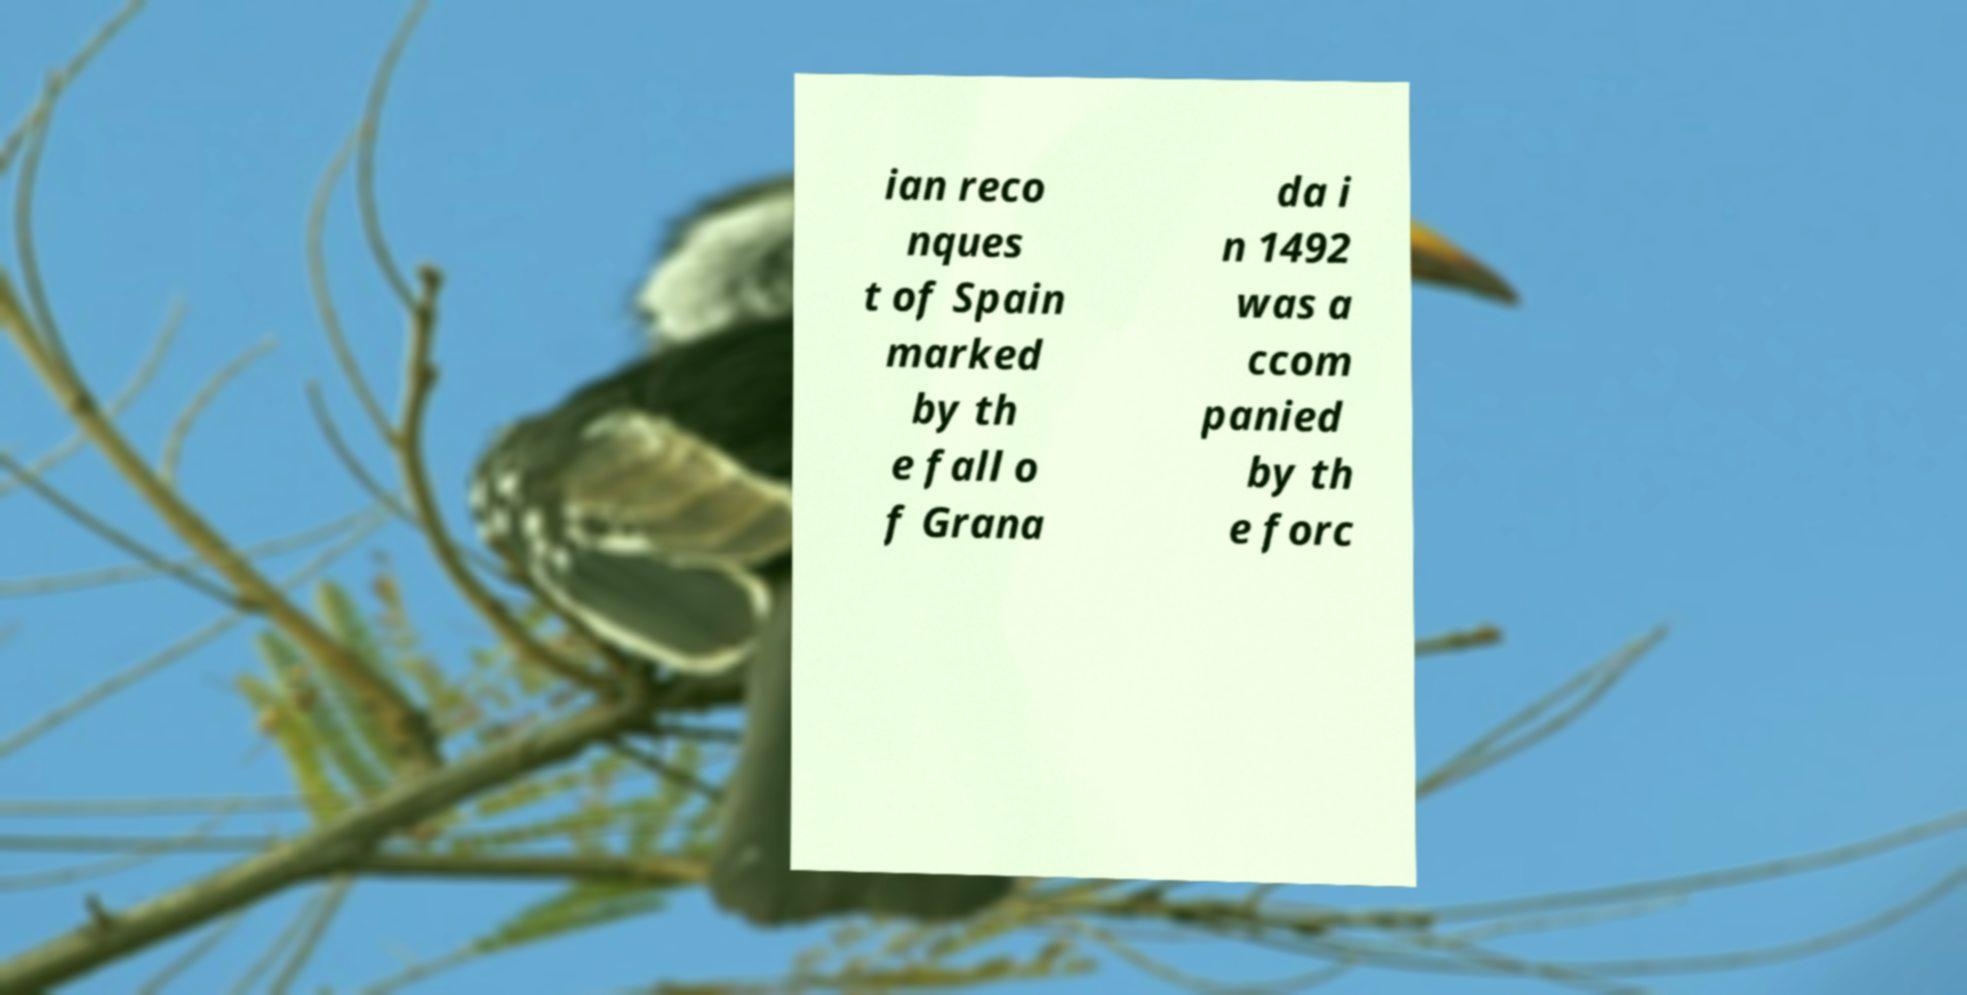Could you assist in decoding the text presented in this image and type it out clearly? ian reco nques t of Spain marked by th e fall o f Grana da i n 1492 was a ccom panied by th e forc 